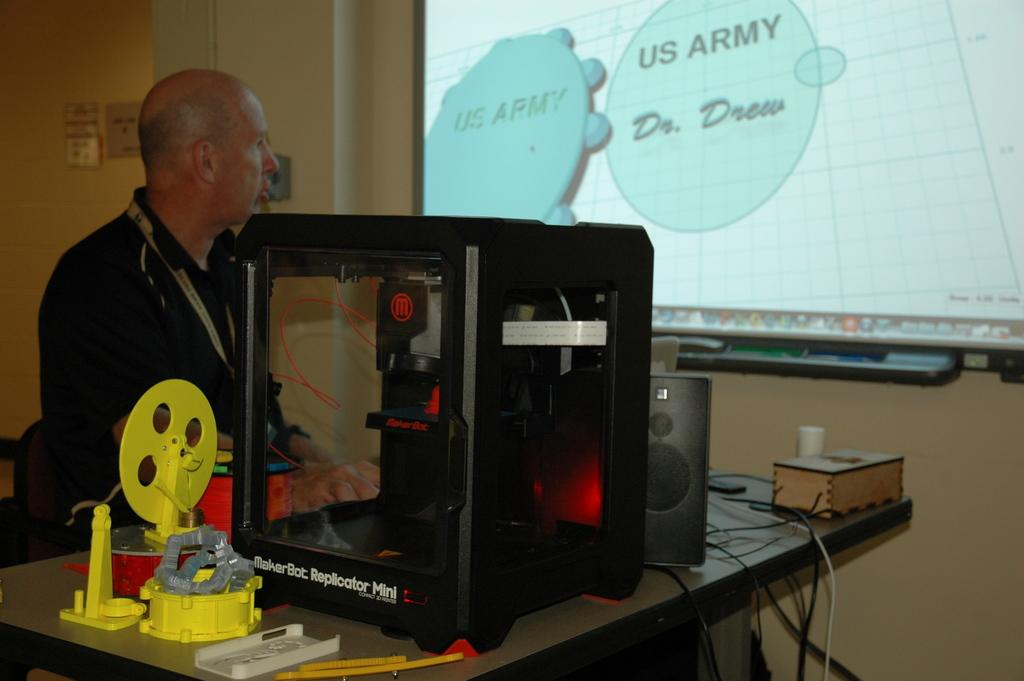What can be found on the table in the image? There are objects, a machine, cables, a box, and a speaker on the table in the image. Can you describe the machine on the table? The machine on the table is not specified in the facts provided. What is connected to the cables on the table? The facts do not specify what the cables are connected to. What is the purpose of the box on the table? The purpose of the box on the table is not specified in the facts provided. What is the man in the background of the image doing? The facts do not specify what the man in the background is doing. What objects are on the wall in the background? The facts do not specify what objects are on the wall in the background. What is displayed on the screen in the background? The facts do not specify what is displayed on the screen in the background. How many eggs are visible on the table in the image? There are no eggs visible on the table in the image. What color is the ink used to write on the objects on the wall in the background? There is no ink or writing present on the objects on the wall in the background. 